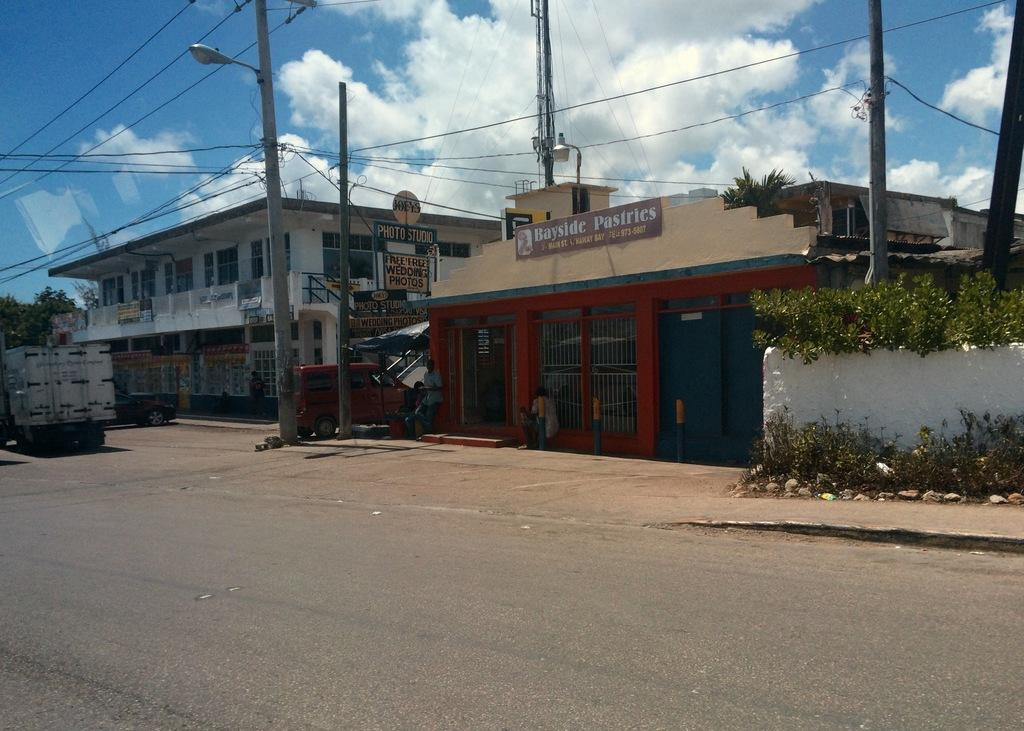What is the main feature of the image? The main feature of the image is a road. What else can be seen in the image? There are buildings, vehicles, plants, poles, wires, boards, a wall, and trees in the image. What is visible in the background of the image? The sky is visible in the background of the image, with clouds present. What language is being spoken by the person in the image? There is no person present in the image, so it is not possible to determine what language might be spoken. 